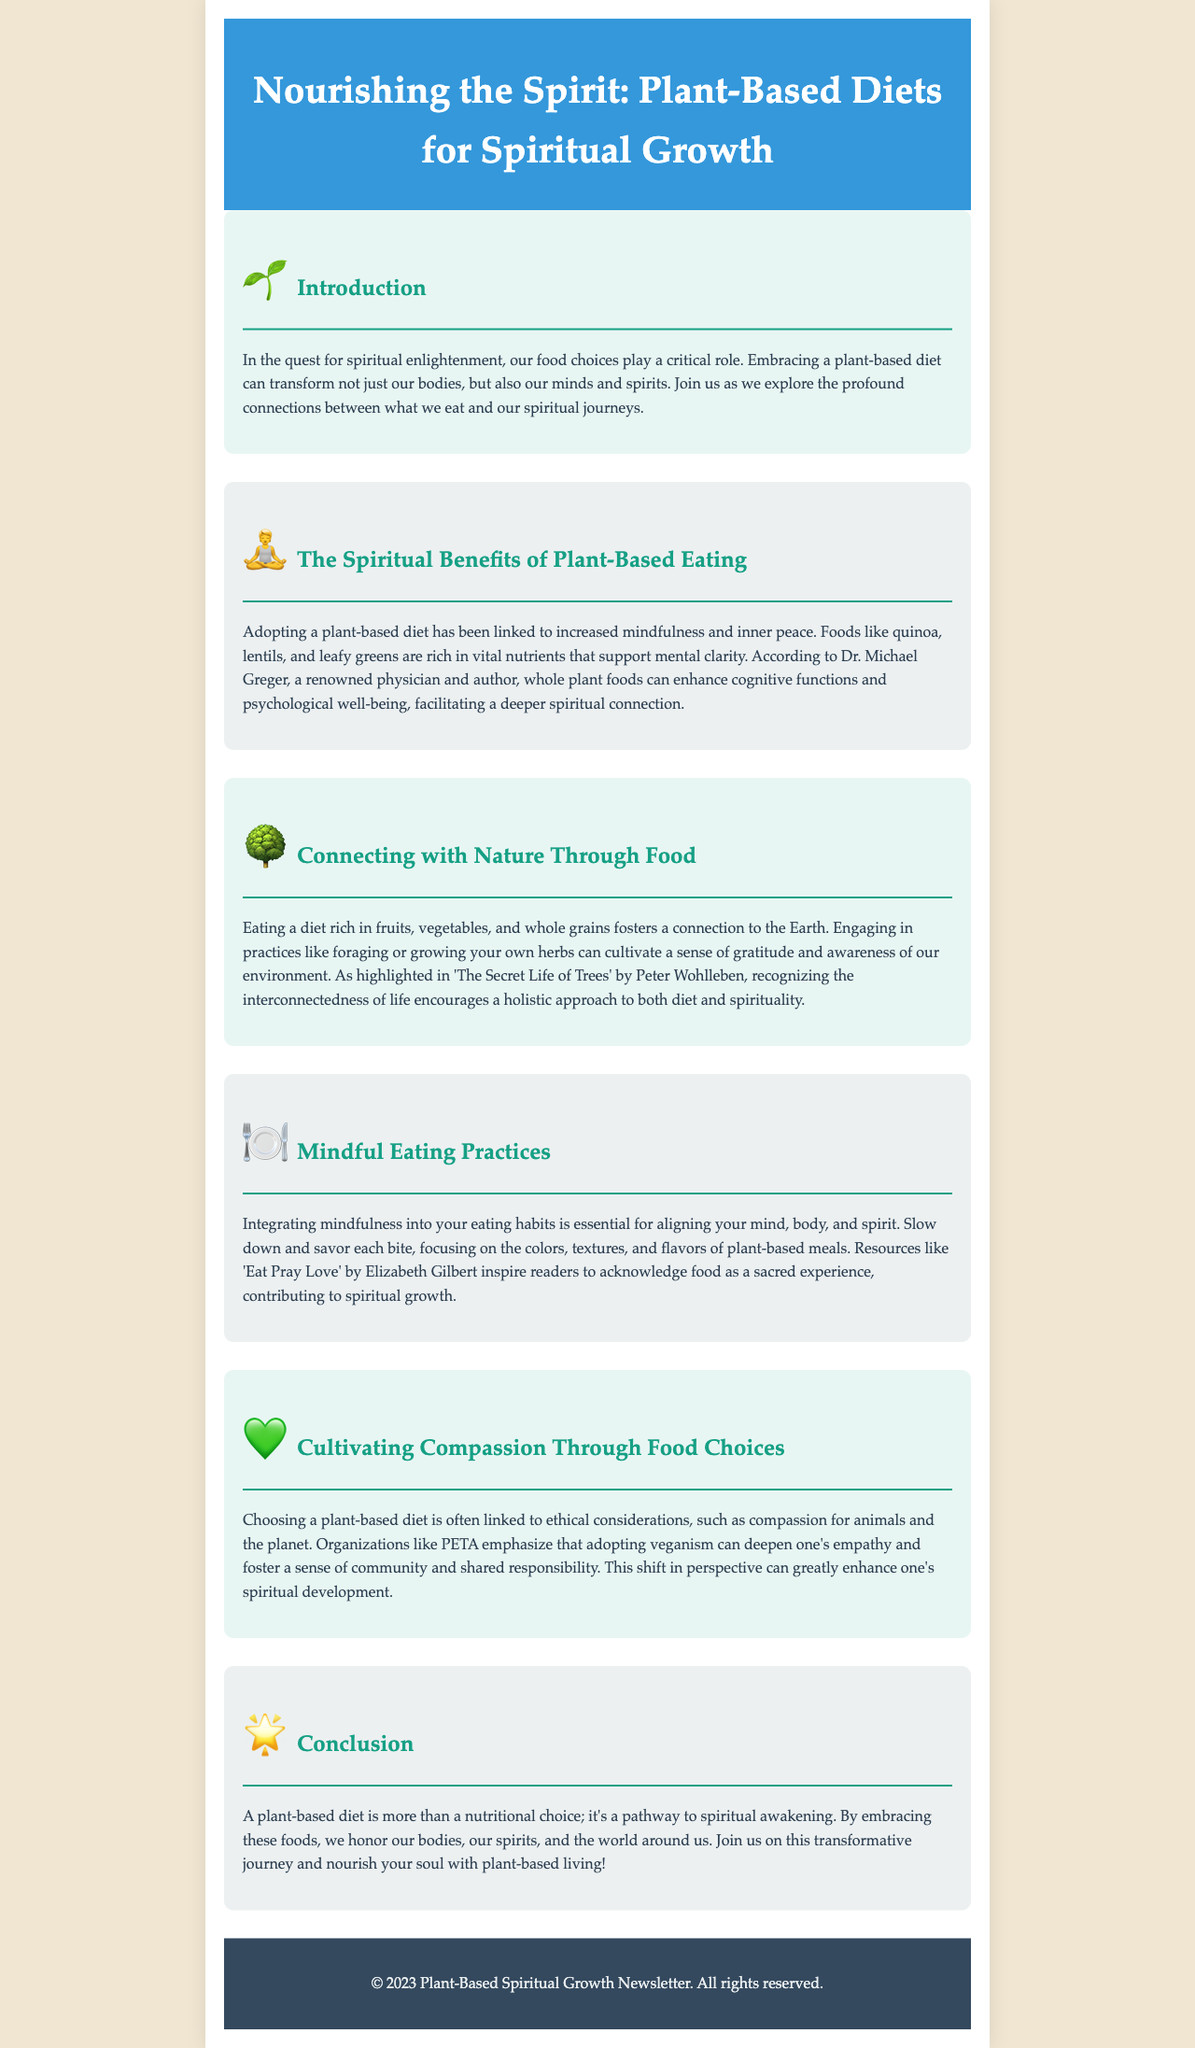what is the title of the newsletter? The title of the newsletter is stated in the header section of the document.
Answer: Nourishing the Spirit: Plant-Based Diets for Spiritual Growth who is a renowned physician mentioned in the document? The document names Dr. Michael Greger, who is acknowledged for his views on plant-based diets.
Answer: Dr. Michael Greger what type of diet is emphasized for spiritual growth? The document clearly indicates the specific type of diet associated with spiritual growth.
Answer: plant-based diet which book correlates food with spiritual experience? A book that inspires readers to treat food as a sacred experience is referenced in the section on mindful eating practices.
Answer: Eat Pray Love what is one benefit of a plant-based diet as mentioned in the newsletter? The document outlines various benefits, one of which enhances mental clarity.
Answer: increased mindfulness which organization is mentioned in relation to compassion for animals? The document references a specific organization that advocates for ethical food choices.
Answer: PETA name a food mentioned that supports mental clarity. The text provides examples of foods that contribute to mental clarity in the spiritual context.
Answer: quinoa what is emphasized as an important practice in mindful eating? The newsletter highlights a key practice that aligns the mind, body, and spirit during meals.
Answer: savoring each bite what does the conclusion suggest about a plant-based diet? The concluding remarks summarize the overarching theme regarding plant-based diets and spiritual awakening.
Answer: pathway to spiritual awakening 